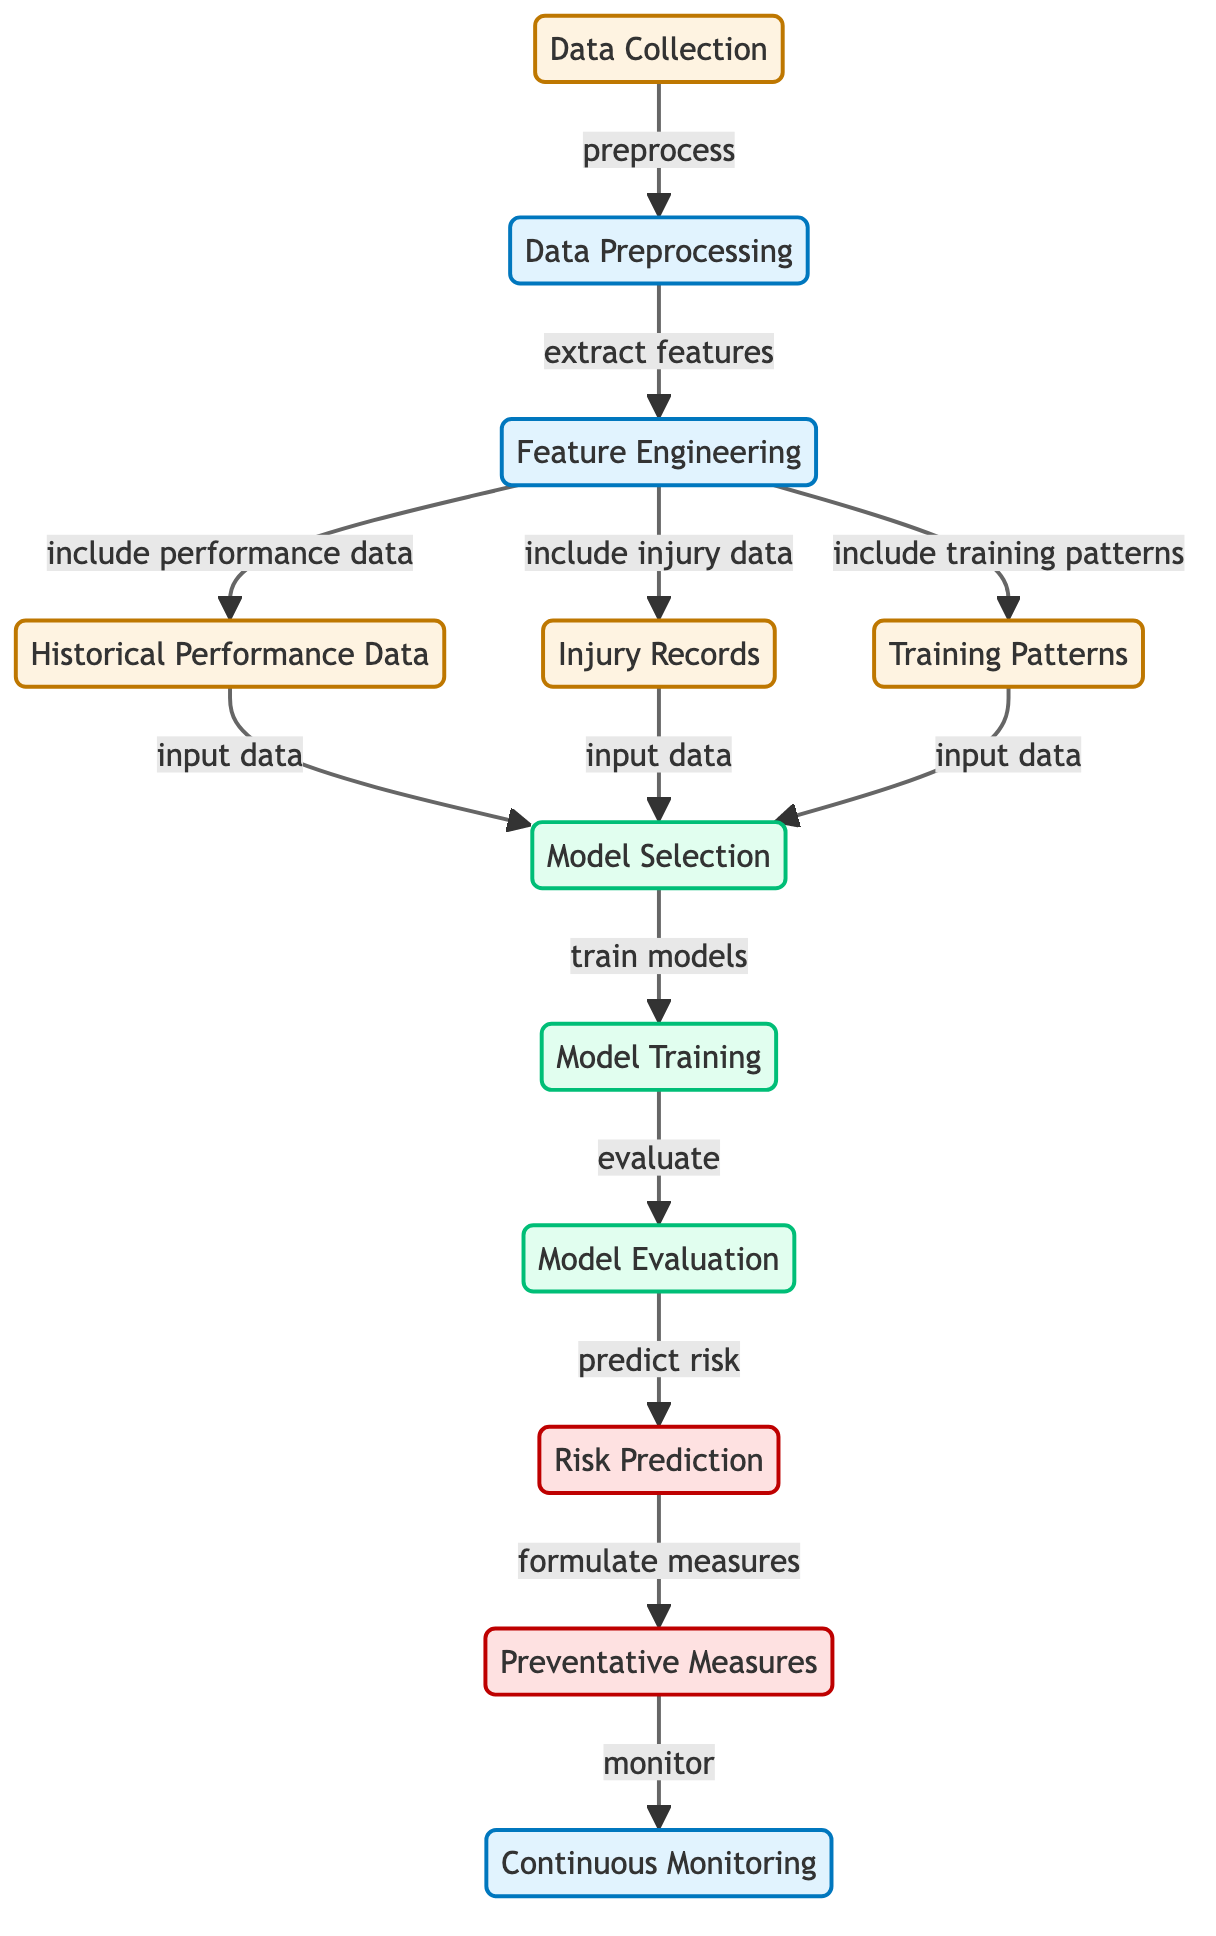What is the first step in the diagram? The diagram begins with "Data Collection," which is the initial node in the process. This node connects to the next step in the flow, which is "Data Preprocessing."
Answer: Data Collection How many types of data are included in feature engineering? There are three specific types of data featured in the "Feature Engineering" node: "Historical Performance Data," "Injury Records," and "Training Patterns." This indicates that the node incorporates multiple data sources.
Answer: Three Which node predicts risk? The node responsible for predicting risk in the diagram is "Risk Prediction." This follows the evaluation of the model.
Answer: Risk Prediction What connects "Model Evaluation" to "Risk Prediction"? The connection between these two nodes is based on the action of "predict risk," indicating that after models are evaluated, they are used to make risk predictions.
Answer: Predict risk Name the final output of the diagram. The diagram has two outputs, but the last one in the flow is "Continuous Monitoring," indicating that it involves ongoing tracking and review of preventative measures.
Answer: Continuous Monitoring What is the process that follows "Model Training"? After "Model Training," the next action is "Model Evaluation." This indicates that after training the model, it is necessary to evaluate its performance before making any predictions.
Answer: Model Evaluation Describe what "Preventative Measures" leads to. "Preventative Measures" leads to "Continuous Monitoring," showing that once measures are formulated based on risk predictions, they require ongoing tracking and assessment to ensure effectiveness.
Answer: Continuous Monitoring How does "Data Preprocessing" connect to "Feature Engineering"? The flow from "Data Preprocessing" to "Feature Engineering" is defined by the action labeled "extract features," indicating that the preprocessing step is intended to prepare the data for feature extraction in the next stage.
Answer: Extract features 